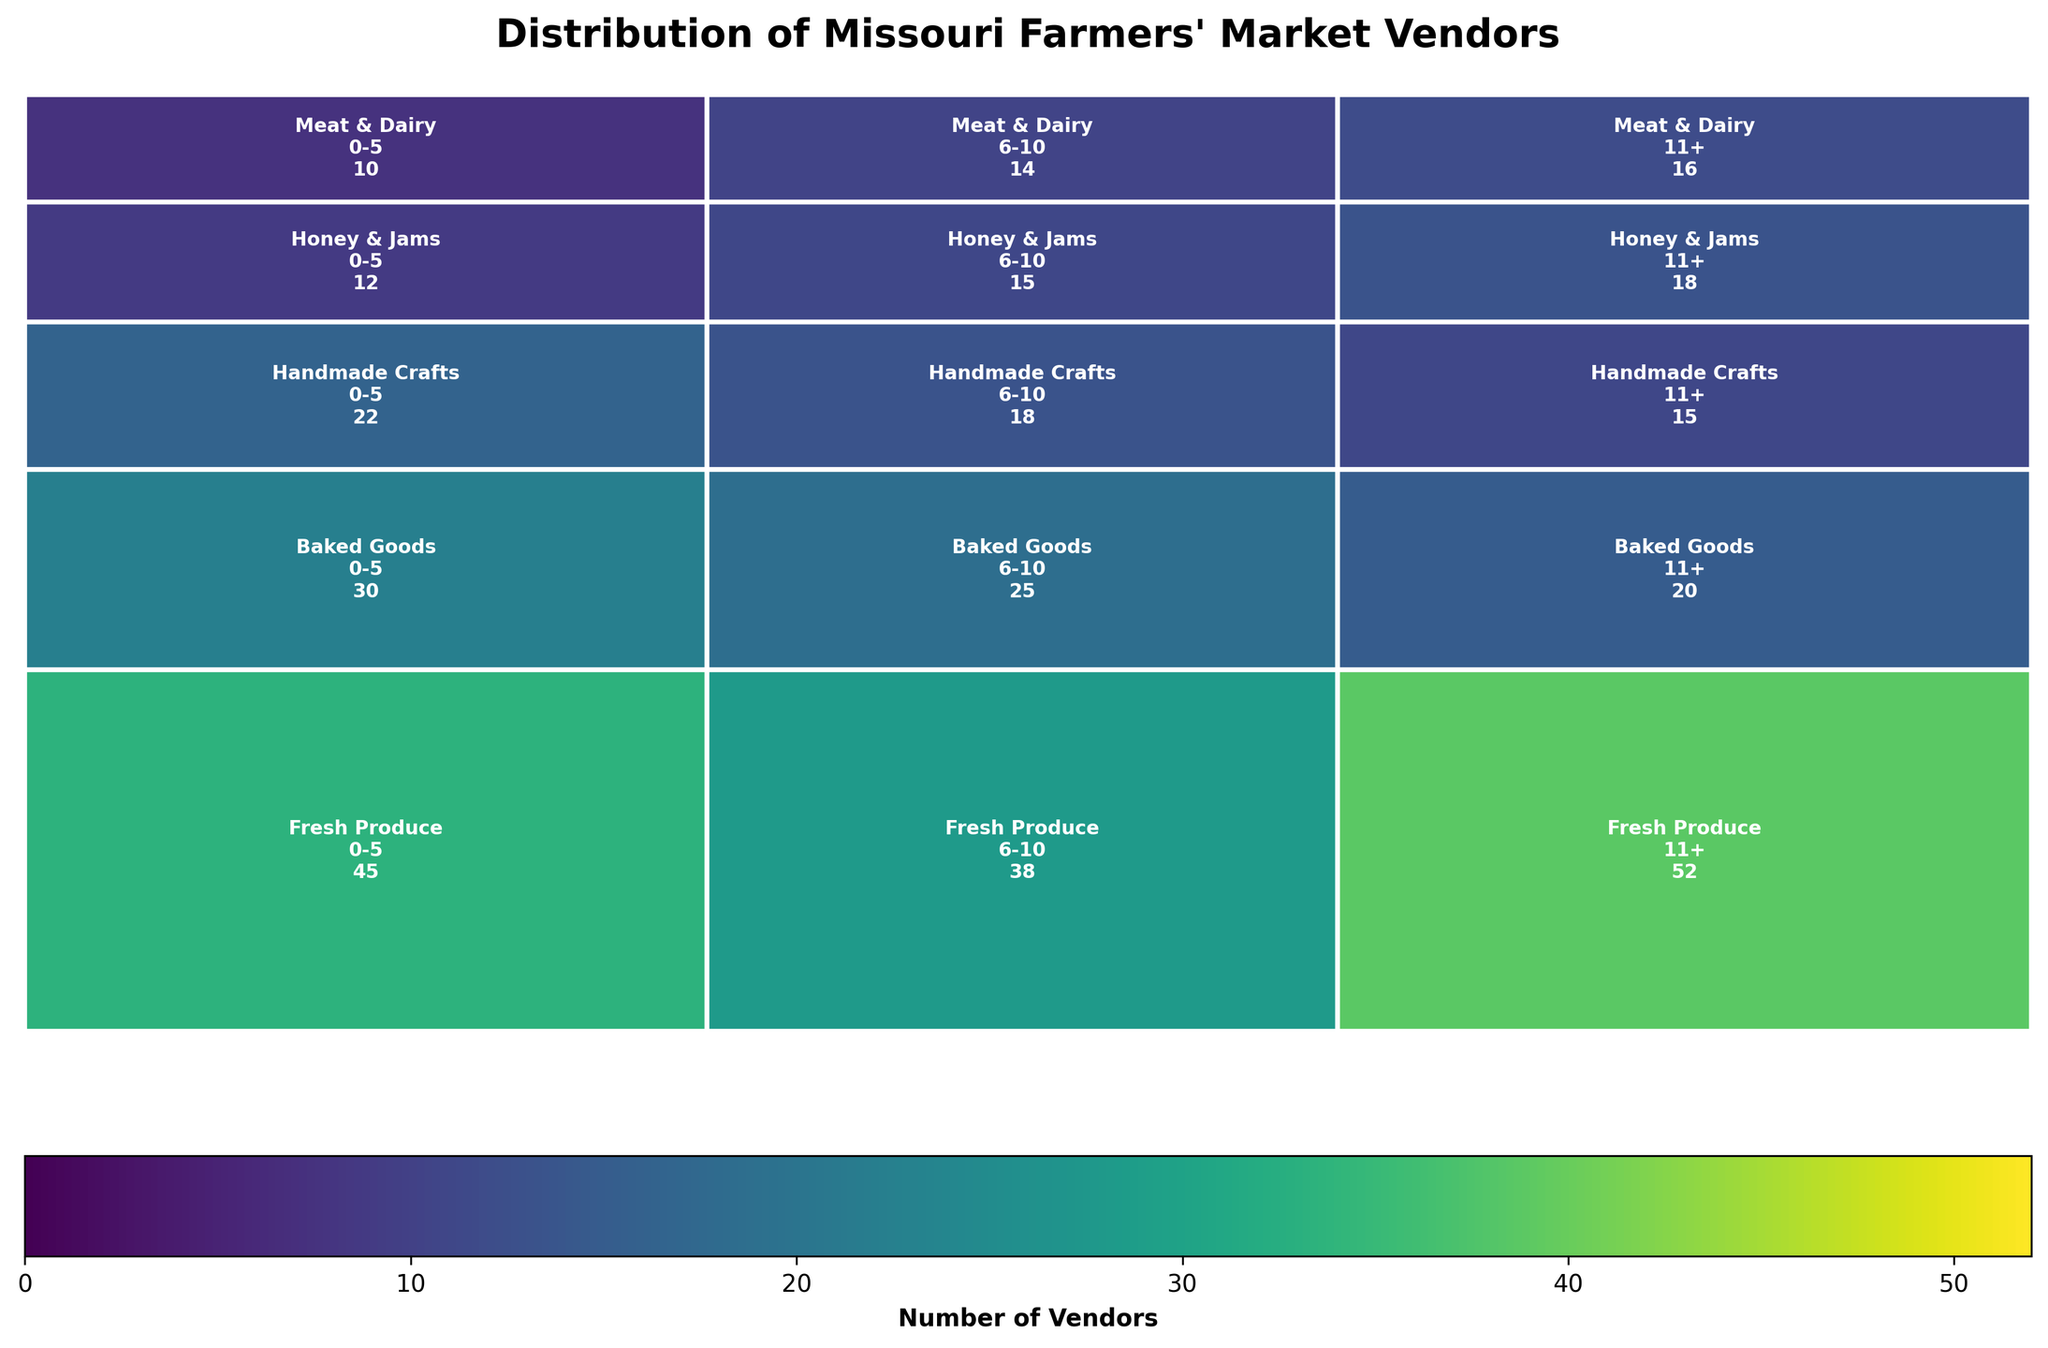What's the title of the figure? The title of the figure is displayed at the top and reads, "Distribution of Missouri Farmers' Market Vendors".
Answer: Distribution of Missouri Farmers' Market Vendors Which product type has the most vendors in the 0-5 years category? By visually examining the rectangles in the plot, the "Fresh Produce" category in the 0-5 years section has the largest area, indicating the highest number of vendors.
Answer: Fresh Produce How many vendors are there for Baked Goods in the 6-10 years category? Locate the rectangle for "Baked Goods" within the "6-10 years" segment. The count displayed within this section is 25.
Answer: 25 Compare the number of vendors for Fresh Produce and Honey & Jams in the 11+ years category. Which one has more? Identify the rectangles for "Fresh Produce" and "Honey & Jams" within the "11+" years section. The count for Fresh Produce is 52, while for Honey & Jams, it is 18. Fresh Produce has more vendors.
Answer: Fresh Produce What is the total number of vendors in the Handmade Crafts category? To find the total, sum the counts for Handmade Crafts across all years categories: 22 (0-5) + 18 (6-10) + 15 (11+). The total is 55.
Answer: 55 Which years category has the highest number of vendors overall across all product types? Sum the counts of each years category across all product types: 0-5 (45+30+22+12+10)=119, 6-10 (38+25+18+15+14)=110, 11+ (52+20+15+18+16)=121. The 11+ category has the highest total.
Answer: 11+ How does the number of vendors for Meat & Dairy in the 0-5 years category compare to the 11+ years category? Identify the counts for Meat & Dairy in both the 0-5 years (10) and 11+ years (16) categories. The 11+ years category has more vendors.
Answer: The 11+ years category has more vendors Which product type has the smallest number of vendors overall? Sum the counts for each product type across all years categories: Fresh Produce (45+38+52)=135, Baked Goods (30+25+20)=75, Handmade Crafts (22+18+15)=55, Honey & Jams (12+15+18)=45, Meat & Dairy (10+14+16)=40. Meat & Dairy has the smallest number overall.
Answer: Meat & Dairy 